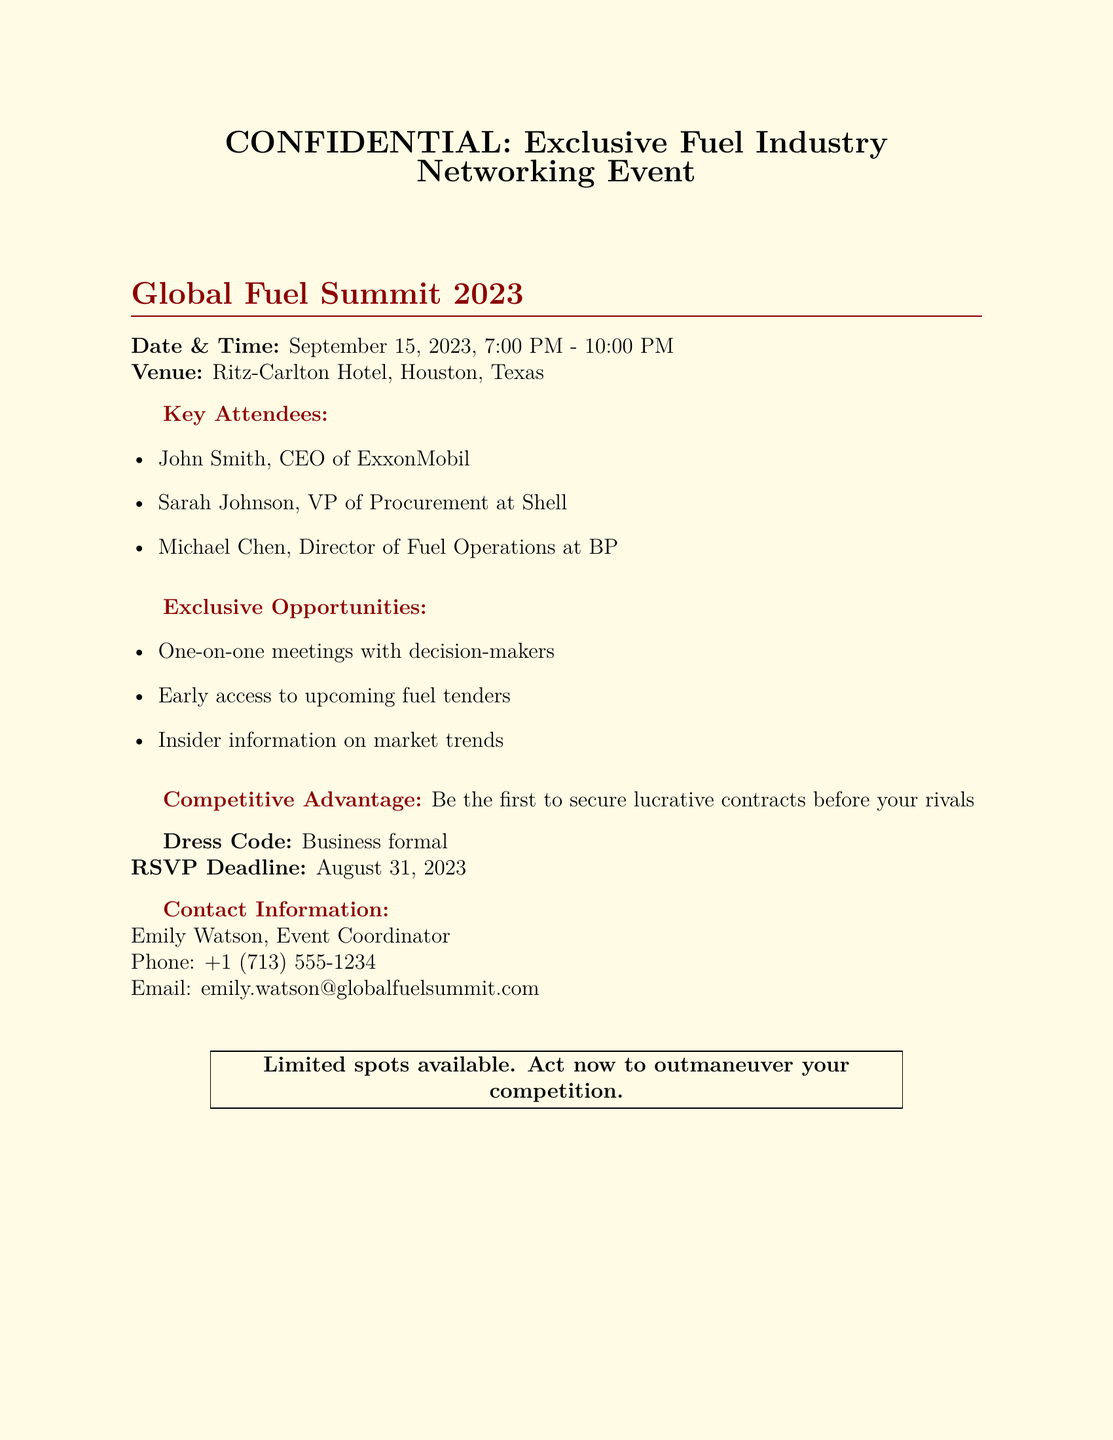What is the date of the event? The date of the event is listed in the document as September 15, 2023.
Answer: September 15, 2023 What time does the event start? The start time is specified in the document as 7:00 PM.
Answer: 7:00 PM Who is the CEO of ExxonMobil? The document lists John Smith as the CEO of ExxonMobil.
Answer: John Smith What is the RSVP deadline? The document provides the RSVP deadline as August 31, 2023.
Answer: August 31, 2023 What type of dress code is required for the event? The dress code specified in the document is business formal.
Answer: Business formal What venue is hosting the event? The venue is mentioned as the Ritz-Carlton Hotel in Houston, Texas.
Answer: Ritz-Carlton Hotel What advantage is highlighted for attendees at the event? The document emphasizes that attendees can secure lucrative contracts before their rivals.
Answer: Secure lucrative contracts What type of opportunities will attendees have? The document mentions opportunities for one-on-one meetings with decision-makers.
Answer: One-on-one meetings How many key attendees are listed in the document? The document lists three key attendees.
Answer: Three 